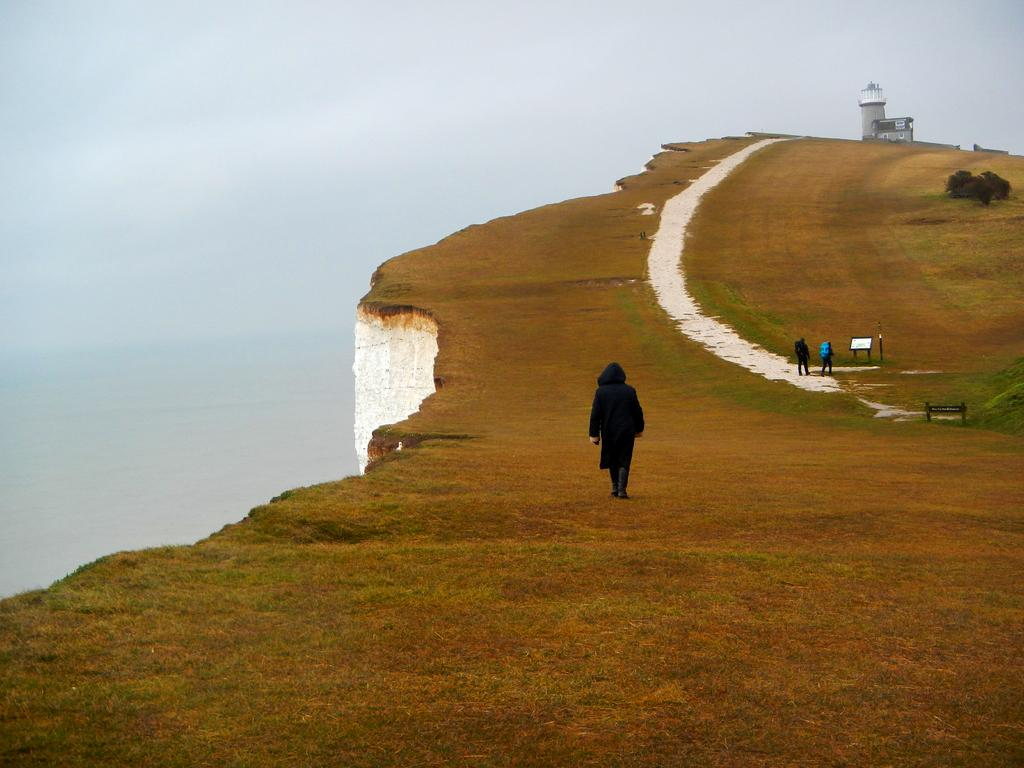What can be seen on the ground in the image? There are people on the ground in the image. What is visible in the background of the image? There is a tower in the background of the image. What type of seating is present in the image? There is a bench in the image. What object can be seen with writing on it? There is a board in the image with writing on it. What type of vegetation is present in the image? There is a tree in the image. Can you describe the location based on the image? The location appears to be high above sea level. What type of oil can be seen dripping from the tree in the image? There is no oil present in the image; it features a tree without any dripping substances. Can you tell me how many times your dad has visited this location? The image does not provide any information about your dad or his visits to this location. 